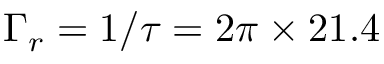<formula> <loc_0><loc_0><loc_500><loc_500>\Gamma _ { r } = 1 / \tau = 2 \pi \times 2 1 . 4</formula> 